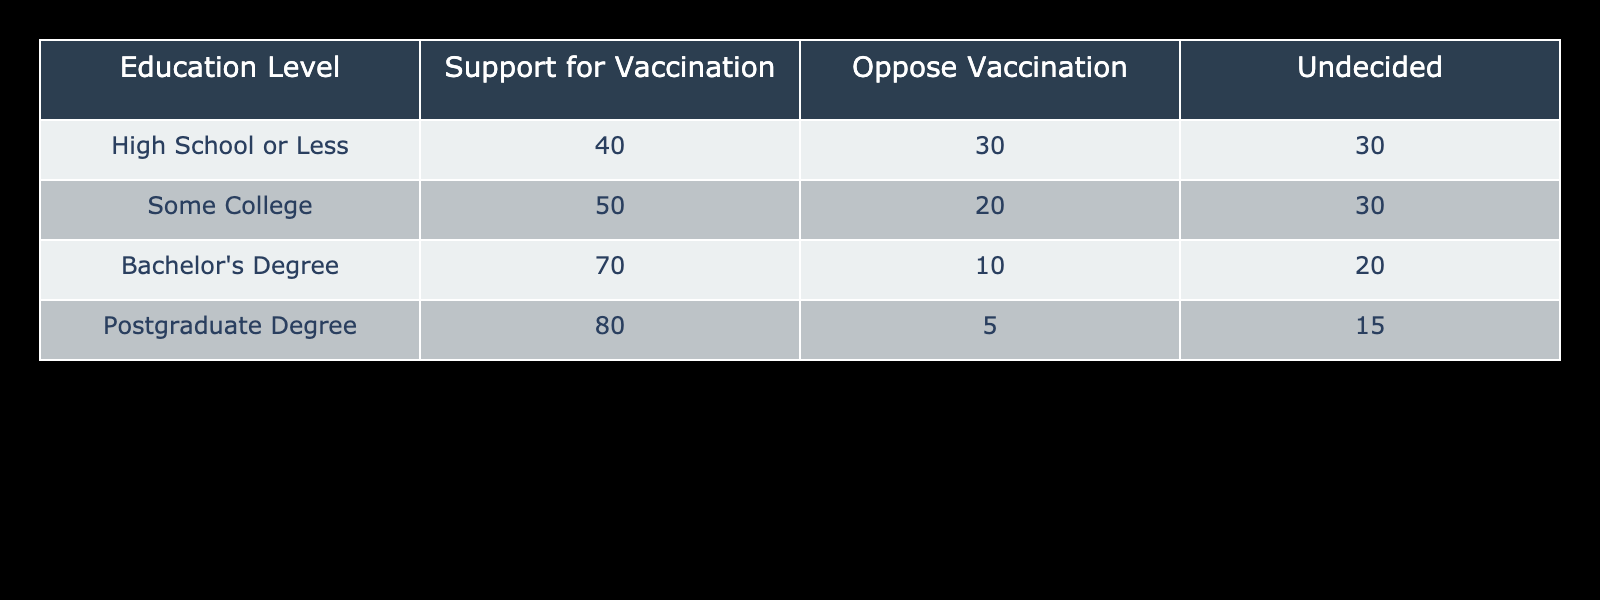What percentage of individuals with a Bachelor's Degree support vaccination? From the table, the number of individuals with a Bachelor's Degree who support vaccination is 70. Since there are no totals provided, we can assume the total is the sum of all responses for that education level: 70 + 10 + 20 = 100. The percentage is then calculated as (70/100) * 100 = 70%.
Answer: 70% What is the total number of people in the "Some College" category? For the "Some College" category, we add the figures together: 50 (support) + 20 (oppose) + 30 (undecided) = 100.
Answer: 100 Is it true that individuals with a Postgraduate Degree are less likely to oppose vaccination than those with a Bachelor’s Degree? From the table, the number opposing vaccination for Postgraduate Degree is 5 and for Bachelor’s Degree is 10. Since 5 < 10, it is true that those with a Postgraduate Degree are less likely to oppose.
Answer: Yes What is the difference in support for vaccination between individuals with a High School education or less and those with a Postgraduate Degree? The support for vaccination for High School or Less is 40 and for Postgraduate Degree it is 80. The difference is calculated as 80 - 40 = 40.
Answer: 40 What proportion of individuals with "Some College" are undecided about vaccination? For the "Some College" category, there are 30 undecided individuals, and the total for that level is 100. The proportion is calculated as 30/100 = 0.30, which is equivalent to 30%.
Answer: 30% If we look at those with a high school education or less, what is the ratio of support to oppose vaccination? For individuals with a High School or Less education, 40 support and 30 oppose. The ratio is then 40:30, which simplifies to 4:3.
Answer: 4:3 Which education level shows the highest percentage of support for vaccination? The highest percentage of support is from individuals with a Postgraduate Degree, which is 80%. This is the largest percentage in the table when compared with all education levels.
Answer: Postgraduate Degree What is the average number of individuals who are undecided across all education levels? The undecided counts for each level are 30, 30, 20, and 15. To find the average, we first add these values together: 30 + 30 + 20 + 15 = 95. Then, dividing by the number of education levels (4) gives 95/4 = 23.75, which rounds to approximately 24 when reporting in whole numbers.
Answer: 24 